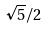Convert formula to latex. <formula><loc_0><loc_0><loc_500><loc_500>\sqrt { 5 } / 2</formula> 